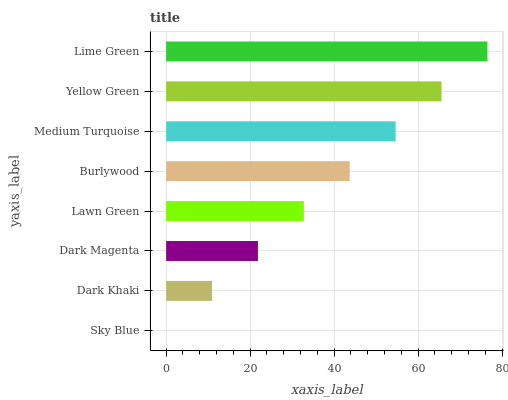Is Sky Blue the minimum?
Answer yes or no. Yes. Is Lime Green the maximum?
Answer yes or no. Yes. Is Dark Khaki the minimum?
Answer yes or no. No. Is Dark Khaki the maximum?
Answer yes or no. No. Is Dark Khaki greater than Sky Blue?
Answer yes or no. Yes. Is Sky Blue less than Dark Khaki?
Answer yes or no. Yes. Is Sky Blue greater than Dark Khaki?
Answer yes or no. No. Is Dark Khaki less than Sky Blue?
Answer yes or no. No. Is Burlywood the high median?
Answer yes or no. Yes. Is Lawn Green the low median?
Answer yes or no. Yes. Is Yellow Green the high median?
Answer yes or no. No. Is Sky Blue the low median?
Answer yes or no. No. 